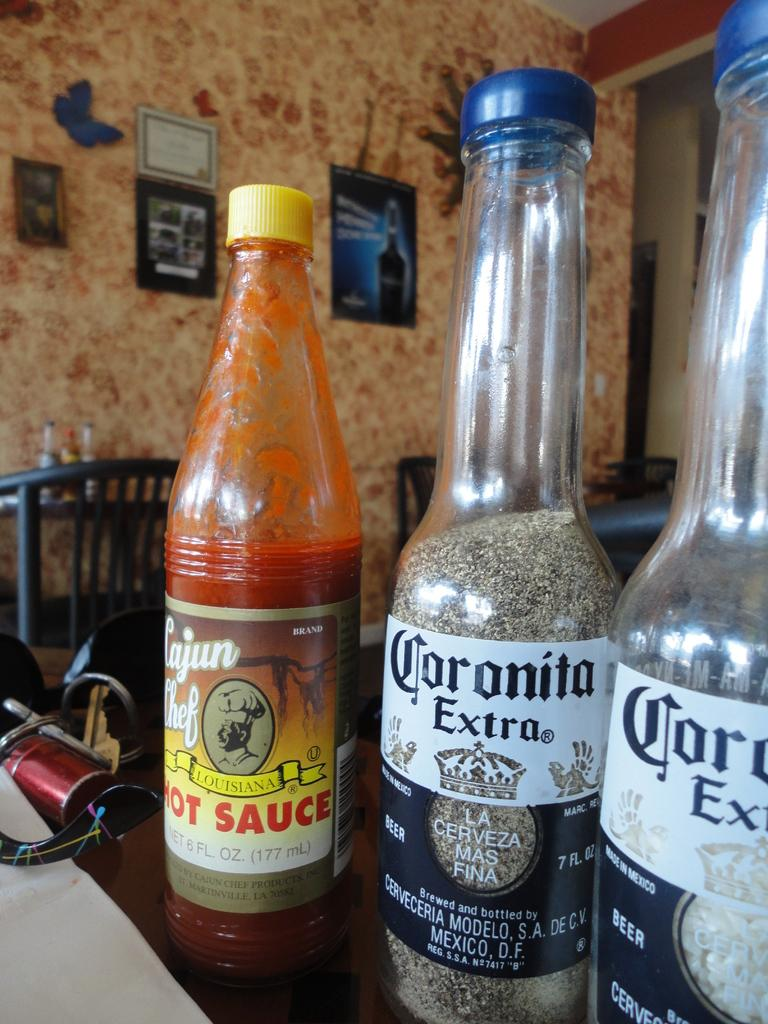Provide a one-sentence caption for the provided image. Two bottles of Coronita Extra filled with salt and pepper. 